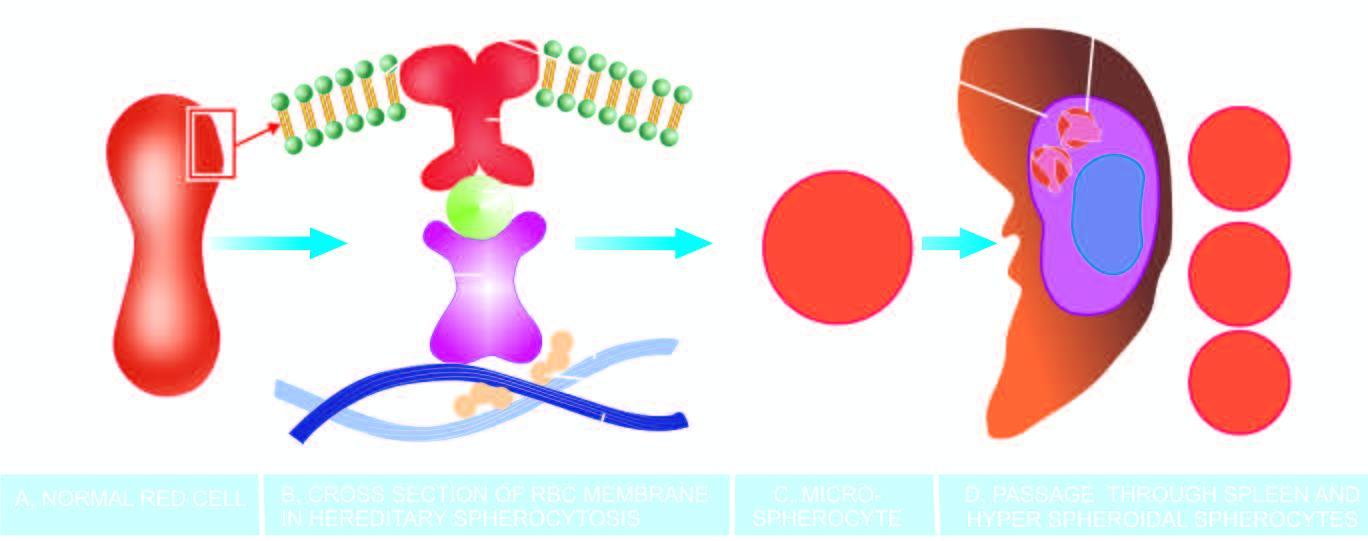do these end components of chromosome result in defect in anchoring of lipid bilayer of the membrane to the underlying cytoskeleton?
Answer the question using a single word or phrase. No 